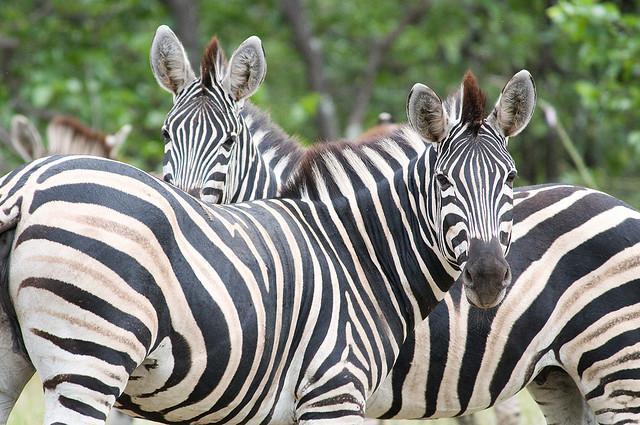How many zebras are standing in the forest with their noses pointed at the cameras?
Make your selection and explain in format: 'Answer: answer
Rationale: rationale.'
Options: Four, three, one, two. Answer: two.
Rationale: There are two zebras looking at the camera. they are easily counted. 